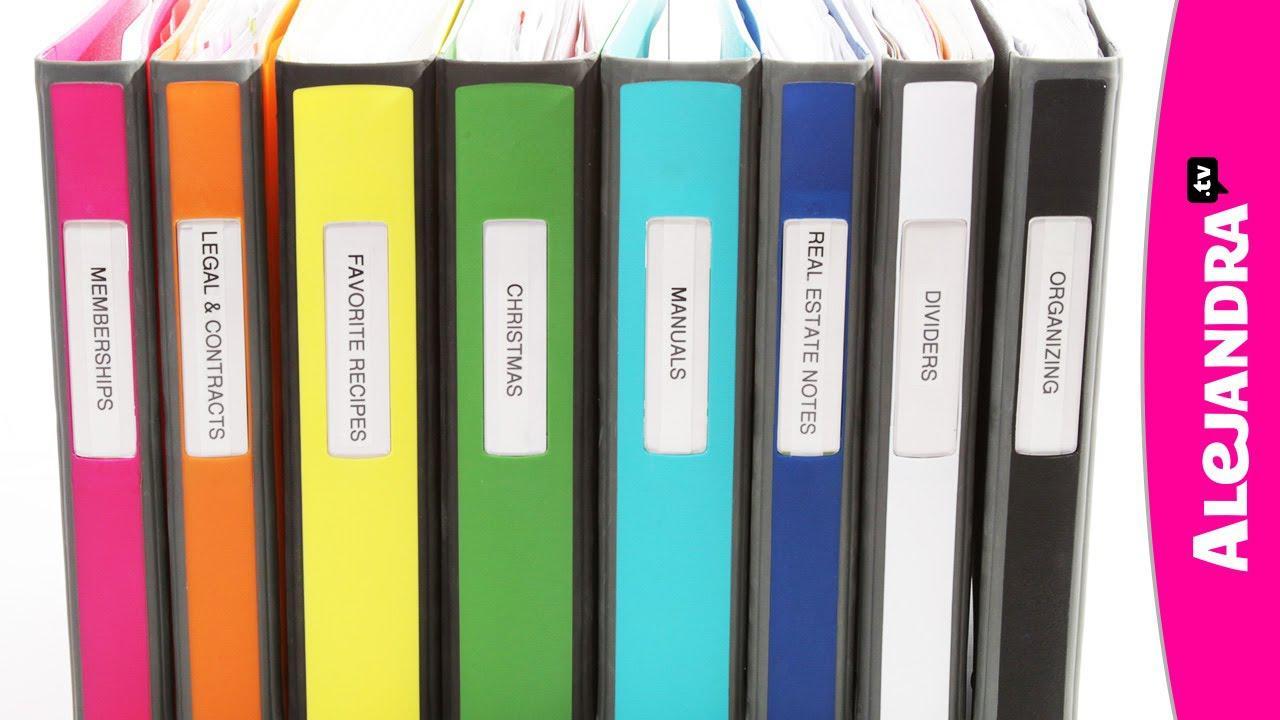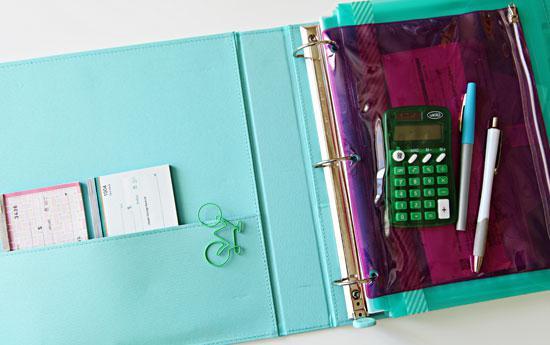The first image is the image on the left, the second image is the image on the right. Evaluate the accuracy of this statement regarding the images: "In one image, a row of notebooks in various colors stands on end, while a second image shows a single notebook open to show three rings and its contents.". Is it true? Answer yes or no. Yes. The first image is the image on the left, the second image is the image on the right. Examine the images to the left and right. Is the description "An image shows one opened binder filled with supplies, including a pen." accurate? Answer yes or no. Yes. 